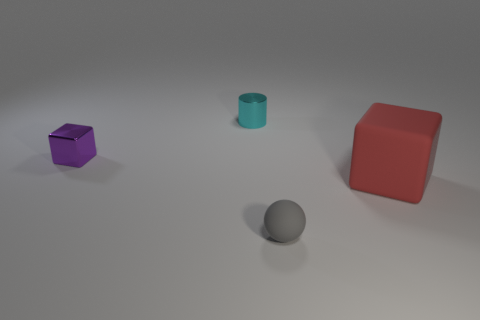There is a tiny thing that is made of the same material as the big red cube; what is its shape?
Your answer should be compact. Sphere. How many things are gray rubber objects or tiny shiny balls?
Your response must be concise. 1. What material is the object behind the tiny object that is left of the cyan metal object?
Ensure brevity in your answer.  Metal. Is there a blue sphere that has the same material as the cyan object?
Make the answer very short. No. There is a small object that is in front of the cube on the left side of the rubber object that is behind the gray rubber ball; what shape is it?
Your response must be concise. Sphere. What is the material of the large thing?
Keep it short and to the point. Rubber. There is a large object that is the same material as the tiny gray sphere; what is its color?
Keep it short and to the point. Red. Is there a small matte thing on the left side of the small shiny thing that is behind the purple metallic thing?
Give a very brief answer. No. What number of other things are the same shape as the small cyan object?
Offer a very short reply. 0. There is a rubber object that is right of the tiny gray matte object; is its shape the same as the metallic object that is behind the small purple thing?
Provide a succinct answer. No. 